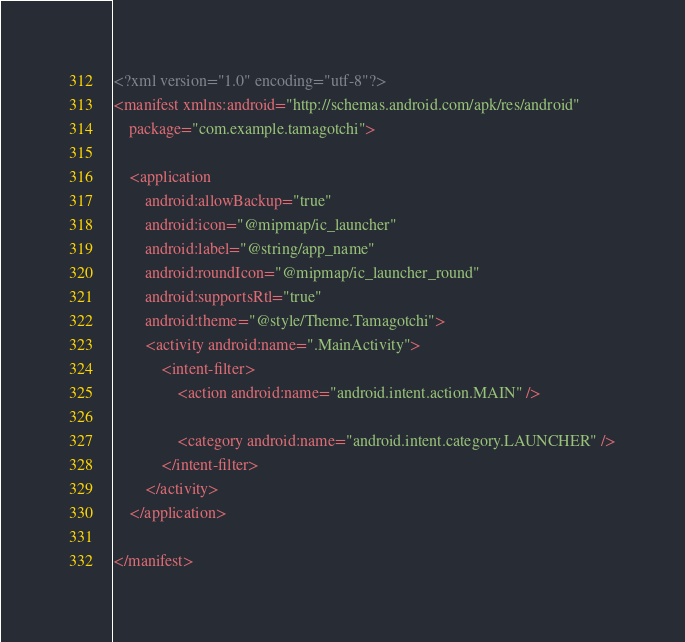<code> <loc_0><loc_0><loc_500><loc_500><_XML_><?xml version="1.0" encoding="utf-8"?>
<manifest xmlns:android="http://schemas.android.com/apk/res/android"
    package="com.example.tamagotchi">

    <application
        android:allowBackup="true"
        android:icon="@mipmap/ic_launcher"
        android:label="@string/app_name"
        android:roundIcon="@mipmap/ic_launcher_round"
        android:supportsRtl="true"
        android:theme="@style/Theme.Tamagotchi">
        <activity android:name=".MainActivity">
            <intent-filter>
                <action android:name="android.intent.action.MAIN" />

                <category android:name="android.intent.category.LAUNCHER" />
            </intent-filter>
        </activity>
    </application>

</manifest></code> 